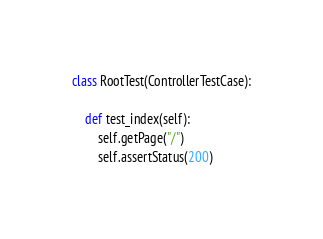Convert code to text. <code><loc_0><loc_0><loc_500><loc_500><_Python_>
class RootTest(ControllerTestCase):

    def test_index(self):
        self.getPage("/")
        self.assertStatus(200)</code> 